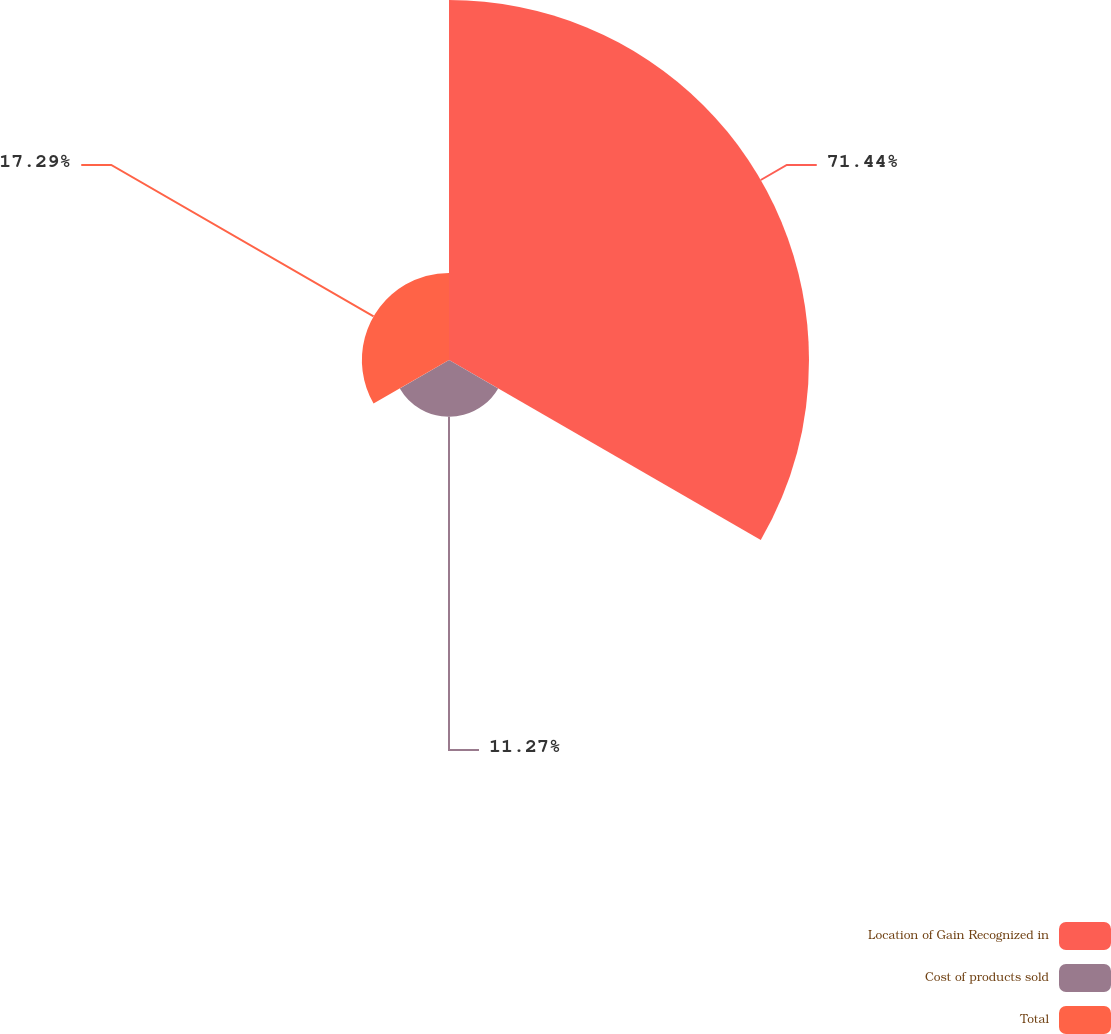<chart> <loc_0><loc_0><loc_500><loc_500><pie_chart><fcel>Location of Gain Recognized in<fcel>Cost of products sold<fcel>Total<nl><fcel>71.45%<fcel>11.27%<fcel>17.29%<nl></chart> 